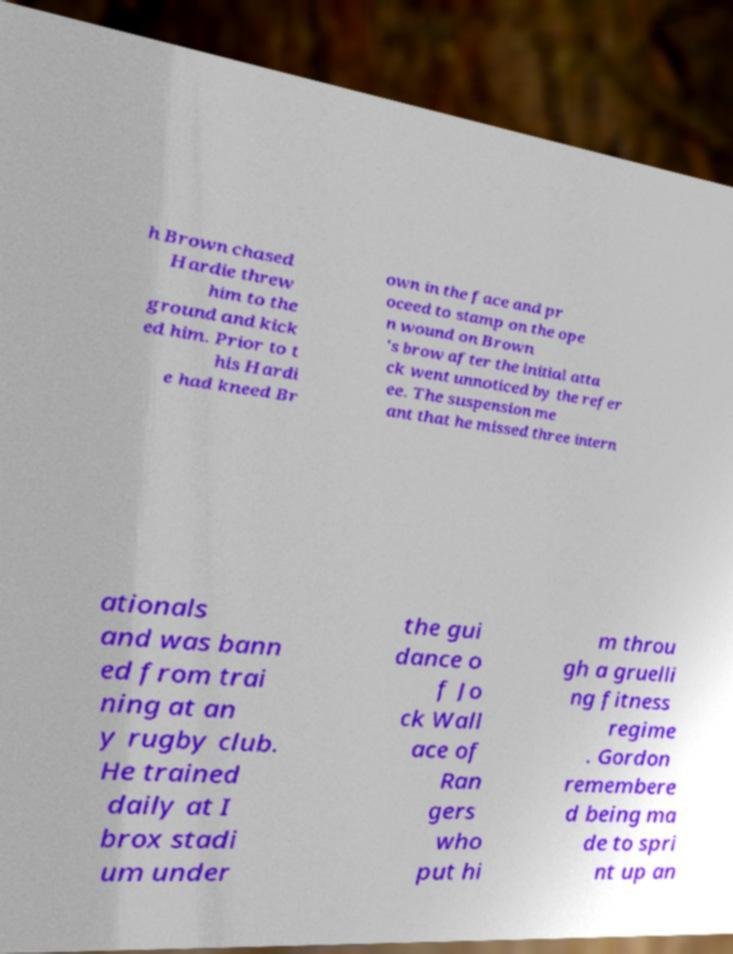Can you read and provide the text displayed in the image?This photo seems to have some interesting text. Can you extract and type it out for me? h Brown chased Hardie threw him to the ground and kick ed him. Prior to t his Hardi e had kneed Br own in the face and pr oceed to stamp on the ope n wound on Brown 's brow after the initial atta ck went unnoticed by the refer ee. The suspension me ant that he missed three intern ationals and was bann ed from trai ning at an y rugby club. He trained daily at I brox stadi um under the gui dance o f Jo ck Wall ace of Ran gers who put hi m throu gh a gruelli ng fitness regime . Gordon remembere d being ma de to spri nt up an 